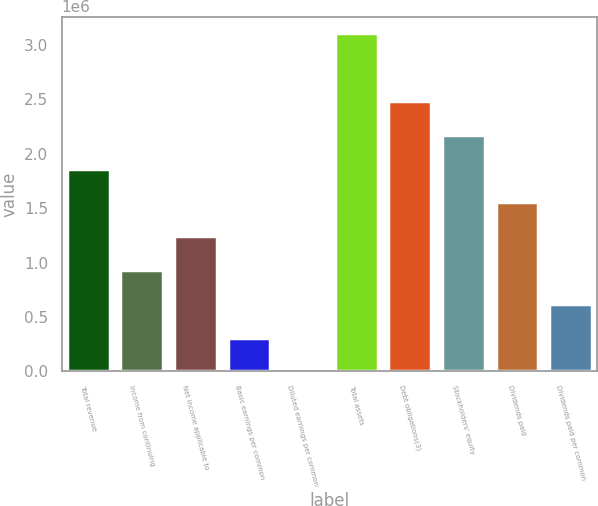<chart> <loc_0><loc_0><loc_500><loc_500><bar_chart><fcel>Total revenue<fcel>Income from continuing<fcel>Net income applicable to<fcel>Basic earnings per common<fcel>Diluted earnings per common<fcel>Total assets<fcel>Debt obligations(3)<fcel>Stockholders' equity<fcel>Dividends paid<fcel>Dividends paid per common<nl><fcel>1.86272e+06<fcel>931358<fcel>1.24181e+06<fcel>310453<fcel>0.54<fcel>3.10453e+06<fcel>2.48362e+06<fcel>2.17317e+06<fcel>1.55226e+06<fcel>620906<nl></chart> 